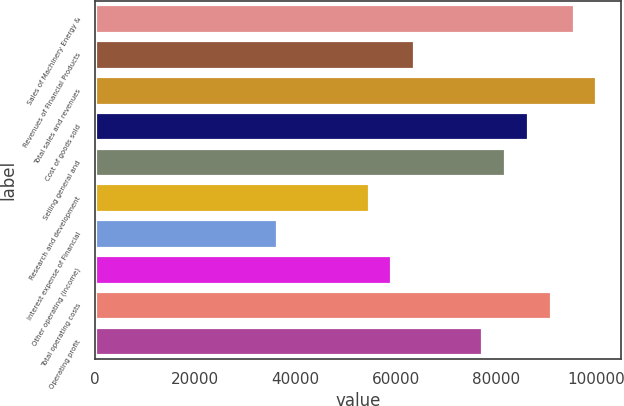<chart> <loc_0><loc_0><loc_500><loc_500><bar_chart><fcel>Sales of Machinery Energy &<fcel>Revenues of Financial Products<fcel>Total sales and revenues<fcel>Cost of goods sold<fcel>Selling general and<fcel>Research and development<fcel>Interest expense of Financial<fcel>Other operating (income)<fcel>Total operating costs<fcel>Operating profit<nl><fcel>95468.7<fcel>63646.2<fcel>100015<fcel>86376.6<fcel>81830.5<fcel>54554.1<fcel>36369.8<fcel>59100.2<fcel>90922.7<fcel>77284.4<nl></chart> 